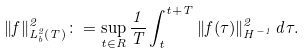<formula> <loc_0><loc_0><loc_500><loc_500>\| f \| ^ { 2 } _ { L ^ { 2 } _ { b } ( T ) } \colon = \sup _ { t \in R } \frac { 1 } { T } \int _ { t } ^ { t + T } \| f ( \tau ) \| _ { H ^ { - 1 } } ^ { 2 } \, d \tau .</formula> 